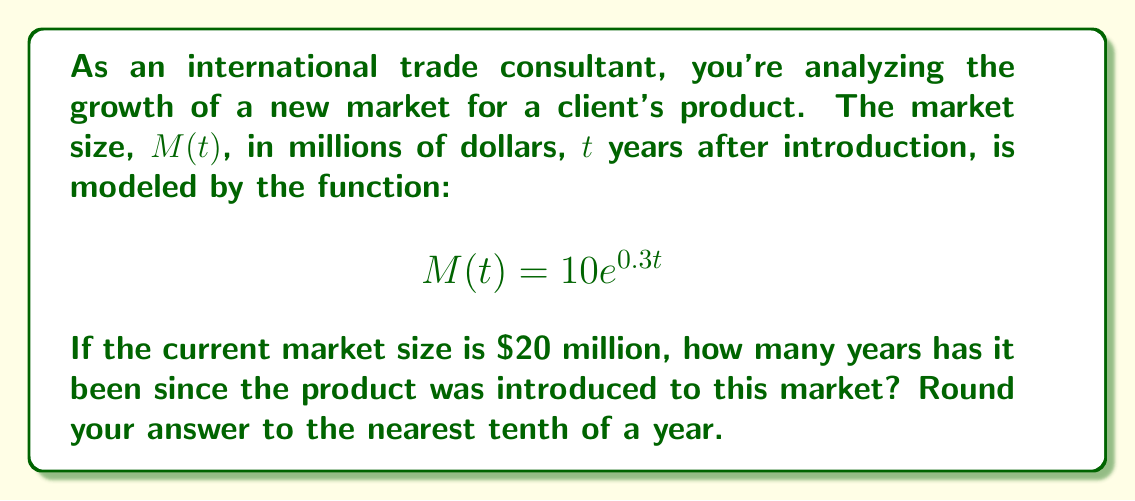Show me your answer to this math problem. Let's approach this step-by-step:

1) We're given the function $M(t) = 10e^{0.3t}$, where $M(t)$ is the market size in millions of dollars and $t$ is the time in years.

2) We're told that the current market size is $20 million. So we can set up the equation:

   $$20 = 10e^{0.3t}$$

3) To solve for $t$, let's first divide both sides by 10:

   $$2 = e^{0.3t}$$

4) Now, we can take the natural logarithm of both sides. Remember, $\ln(e^x) = x$:

   $$\ln(2) = \ln(e^{0.3t})$$
   $$\ln(2) = 0.3t$$

5) Now we can solve for $t$ by dividing both sides by 0.3:

   $$t = \frac{\ln(2)}{0.3}$$

6) Let's calculate this:
   
   $$t = \frac{0.6931...}{0.3} = 2.3104...$$

7) Rounding to the nearest tenth of a year:

   $$t \approx 2.3 \text{ years}$$
Answer: 2.3 years 